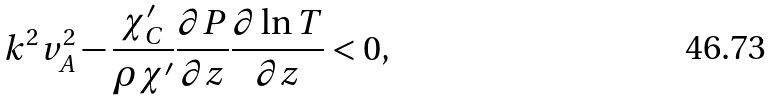Convert formula to latex. <formula><loc_0><loc_0><loc_500><loc_500>k ^ { 2 } v _ { A } ^ { 2 } - \frac { \chi ^ { \prime } _ { C } } { \rho \chi ^ { \prime } } \frac { \partial P } { \partial z } \frac { \partial \ln T } { \partial z } < 0 ,</formula> 